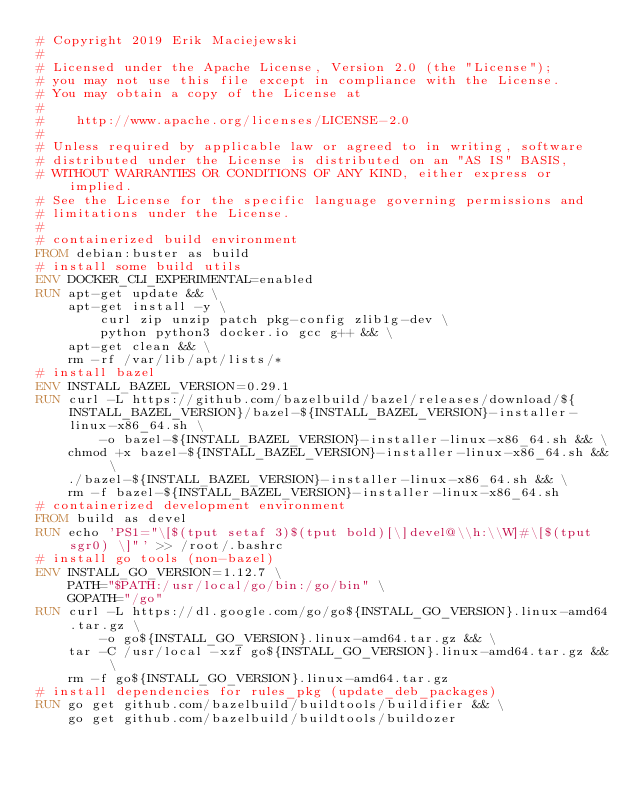Convert code to text. <code><loc_0><loc_0><loc_500><loc_500><_Dockerfile_># Copyright 2019 Erik Maciejewski
#
# Licensed under the Apache License, Version 2.0 (the "License");
# you may not use this file except in compliance with the License.
# You may obtain a copy of the License at
#
#    http://www.apache.org/licenses/LICENSE-2.0
#
# Unless required by applicable law or agreed to in writing, software
# distributed under the License is distributed on an "AS IS" BASIS,
# WITHOUT WARRANTIES OR CONDITIONS OF ANY KIND, either express or implied.
# See the License for the specific language governing permissions and
# limitations under the License.
#
# containerized build environment
FROM debian:buster as build
# install some build utils
ENV DOCKER_CLI_EXPERIMENTAL=enabled
RUN apt-get update && \
    apt-get install -y \
        curl zip unzip patch pkg-config zlib1g-dev \
        python python3 docker.io gcc g++ && \
    apt-get clean && \
    rm -rf /var/lib/apt/lists/*
# install bazel
ENV INSTALL_BAZEL_VERSION=0.29.1
RUN curl -L https://github.com/bazelbuild/bazel/releases/download/${INSTALL_BAZEL_VERSION}/bazel-${INSTALL_BAZEL_VERSION}-installer-linux-x86_64.sh \
        -o bazel-${INSTALL_BAZEL_VERSION}-installer-linux-x86_64.sh && \
    chmod +x bazel-${INSTALL_BAZEL_VERSION}-installer-linux-x86_64.sh && \
    ./bazel-${INSTALL_BAZEL_VERSION}-installer-linux-x86_64.sh && \
    rm -f bazel-${INSTALL_BAZEL_VERSION}-installer-linux-x86_64.sh
# containerized development environment
FROM build as devel
RUN echo 'PS1="\[$(tput setaf 3)$(tput bold)[\]devel@\\h:\\W]#\[$(tput sgr0) \]"' >> /root/.bashrc
# install go tools (non-bazel)
ENV INSTALL_GO_VERSION=1.12.7 \
    PATH="$PATH:/usr/local/go/bin:/go/bin" \
    GOPATH="/go"
RUN curl -L https://dl.google.com/go/go${INSTALL_GO_VERSION}.linux-amd64.tar.gz \
        -o go${INSTALL_GO_VERSION}.linux-amd64.tar.gz && \
    tar -C /usr/local -xzf go${INSTALL_GO_VERSION}.linux-amd64.tar.gz && \
    rm -f go${INSTALL_GO_VERSION}.linux-amd64.tar.gz
# install dependencies for rules_pkg (update_deb_packages)
RUN go get github.com/bazelbuild/buildtools/buildifier && \
    go get github.com/bazelbuild/buildtools/buildozer
</code> 